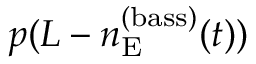Convert formula to latex. <formula><loc_0><loc_0><loc_500><loc_500>p ( L - n _ { E } ^ { ( b a s s ) } ( t ) )</formula> 